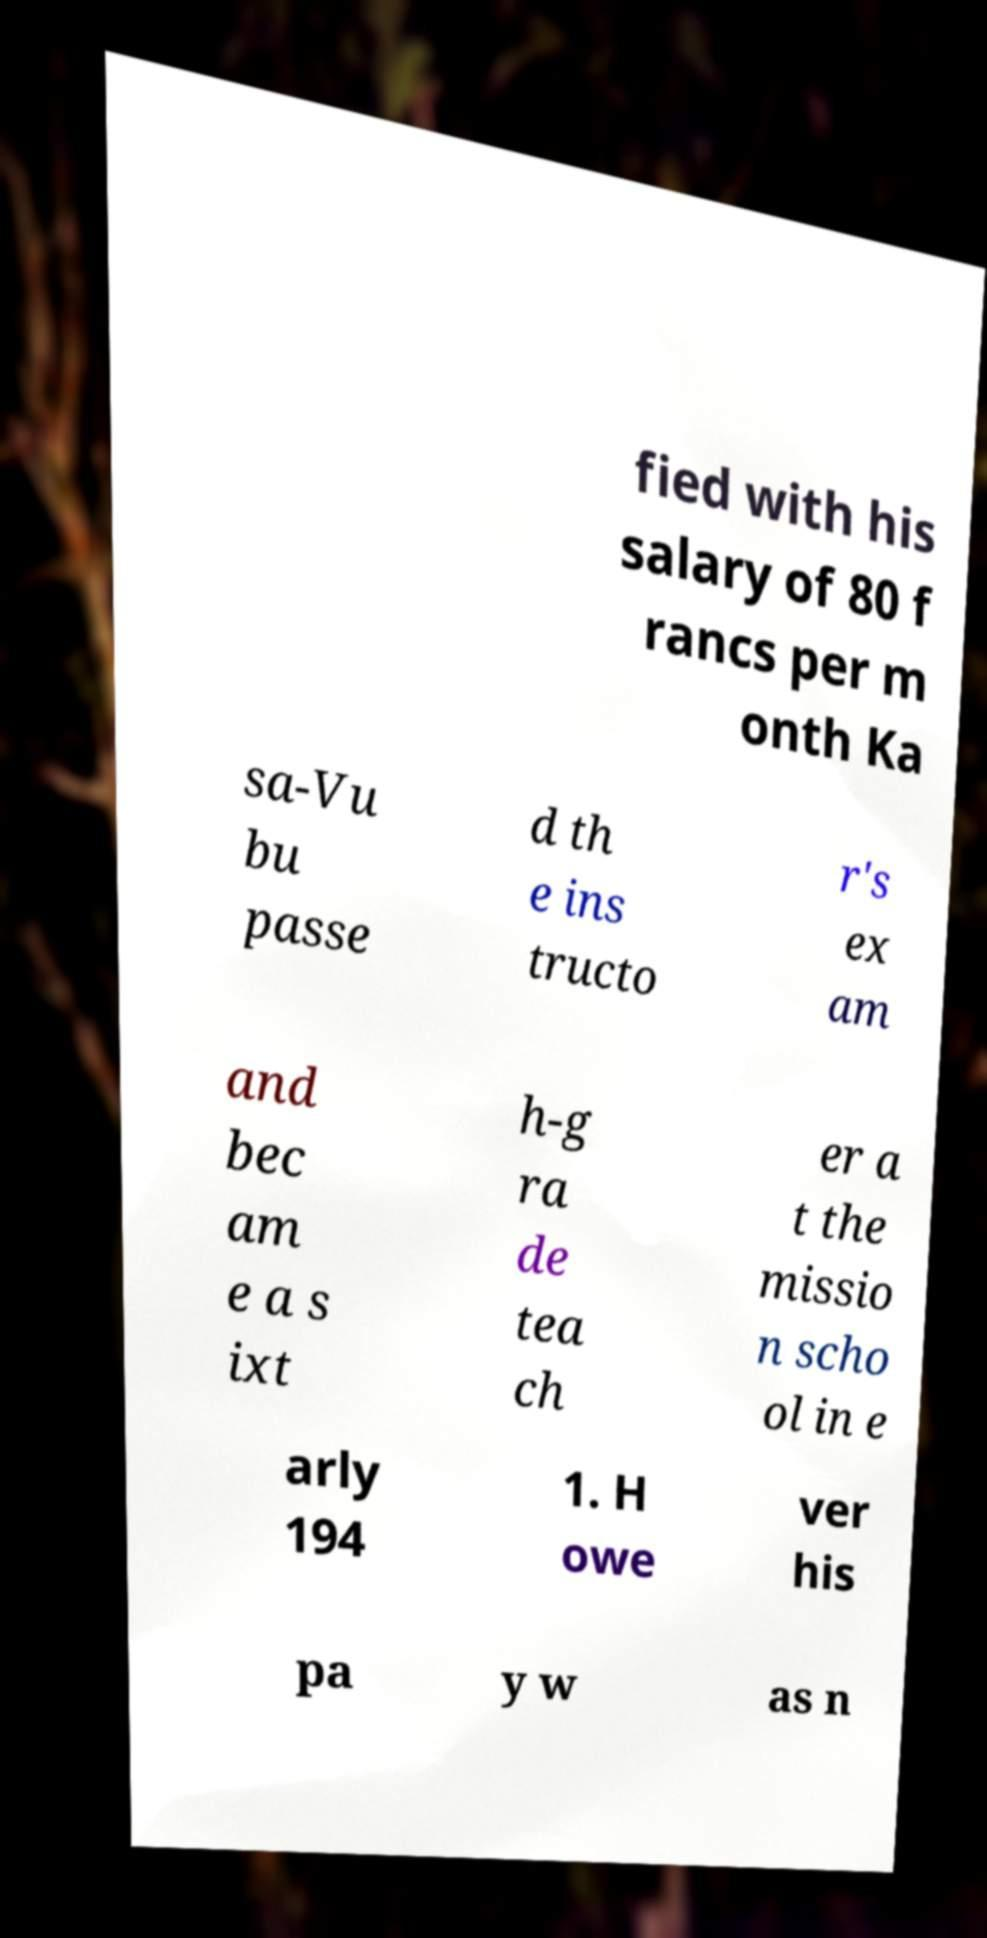For documentation purposes, I need the text within this image transcribed. Could you provide that? fied with his salary of 80 f rancs per m onth Ka sa-Vu bu passe d th e ins tructo r's ex am and bec am e a s ixt h-g ra de tea ch er a t the missio n scho ol in e arly 194 1. H owe ver his pa y w as n 